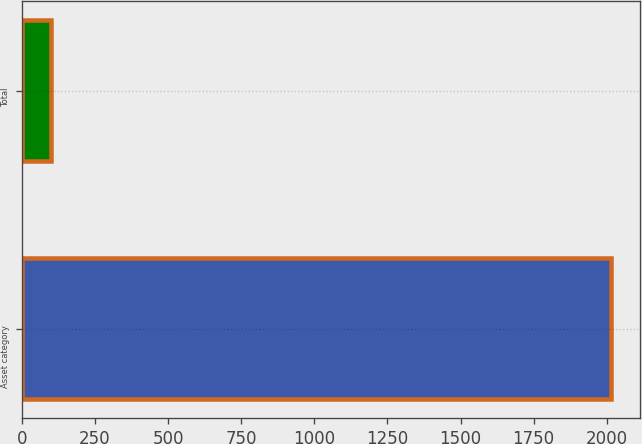<chart> <loc_0><loc_0><loc_500><loc_500><bar_chart><fcel>Asset category<fcel>Total<nl><fcel>2013<fcel>100<nl></chart> 